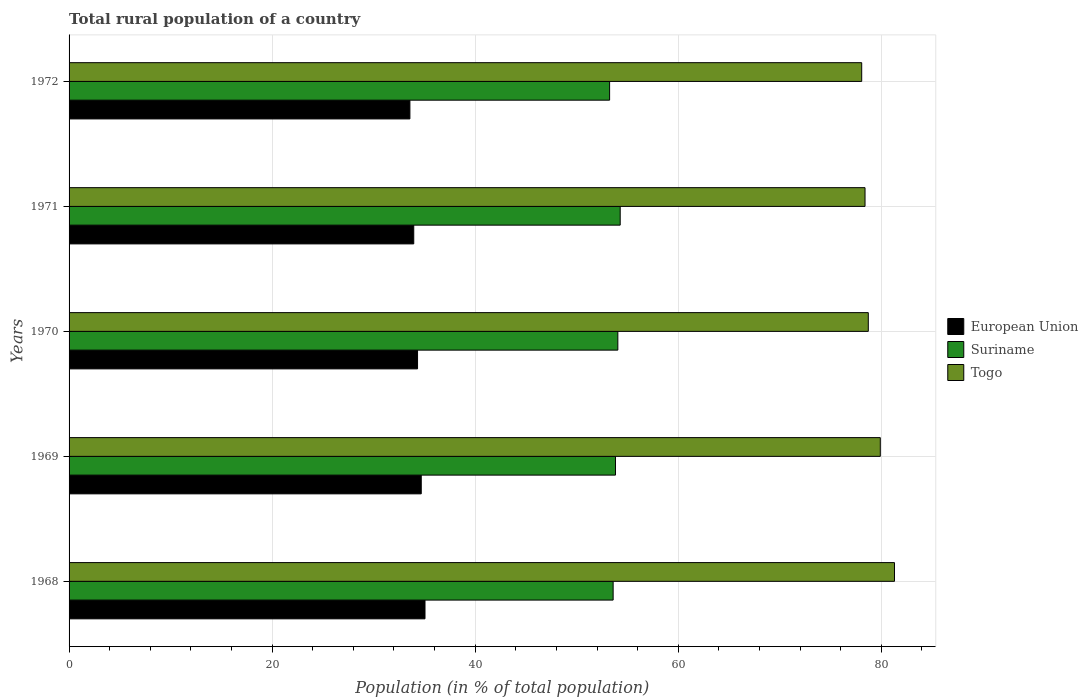How many different coloured bars are there?
Keep it short and to the point. 3. How many bars are there on the 5th tick from the top?
Give a very brief answer. 3. How many bars are there on the 5th tick from the bottom?
Your answer should be very brief. 3. What is the rural population in Togo in 1969?
Ensure brevity in your answer.  79.9. Across all years, what is the maximum rural population in Togo?
Offer a terse response. 81.3. Across all years, what is the minimum rural population in Togo?
Offer a terse response. 78.07. In which year was the rural population in Togo maximum?
Provide a short and direct response. 1968. In which year was the rural population in Suriname minimum?
Make the answer very short. 1972. What is the total rural population in European Union in the graph?
Provide a succinct answer. 171.59. What is the difference between the rural population in Togo in 1971 and that in 1972?
Keep it short and to the point. 0.33. What is the difference between the rural population in Togo in 1971 and the rural population in European Union in 1969?
Offer a terse response. 43.71. What is the average rural population in Suriname per year?
Provide a short and direct response. 53.8. In the year 1971, what is the difference between the rural population in European Union and rural population in Togo?
Offer a very short reply. -44.45. In how many years, is the rural population in Suriname greater than 64 %?
Provide a succinct answer. 0. What is the ratio of the rural population in Togo in 1968 to that in 1971?
Offer a very short reply. 1.04. What is the difference between the highest and the second highest rural population in Togo?
Your answer should be very brief. 1.4. What is the difference between the highest and the lowest rural population in European Union?
Give a very brief answer. 1.49. In how many years, is the rural population in European Union greater than the average rural population in European Union taken over all years?
Your answer should be very brief. 3. Is the sum of the rural population in Togo in 1968 and 1972 greater than the maximum rural population in European Union across all years?
Provide a short and direct response. Yes. What does the 3rd bar from the top in 1968 represents?
Your answer should be compact. European Union. What does the 2nd bar from the bottom in 1968 represents?
Your response must be concise. Suriname. Is it the case that in every year, the sum of the rural population in Suriname and rural population in European Union is greater than the rural population in Togo?
Provide a short and direct response. Yes. How many bars are there?
Offer a terse response. 15. How many years are there in the graph?
Make the answer very short. 5. Does the graph contain grids?
Your answer should be compact. Yes. Where does the legend appear in the graph?
Your answer should be compact. Center right. How many legend labels are there?
Keep it short and to the point. 3. How are the legend labels stacked?
Offer a terse response. Vertical. What is the title of the graph?
Make the answer very short. Total rural population of a country. Does "Aruba" appear as one of the legend labels in the graph?
Ensure brevity in your answer.  No. What is the label or title of the X-axis?
Offer a very short reply. Population (in % of total population). What is the Population (in % of total population) in European Union in 1968?
Offer a terse response. 35.06. What is the Population (in % of total population) of Suriname in 1968?
Provide a short and direct response. 53.59. What is the Population (in % of total population) of Togo in 1968?
Your response must be concise. 81.3. What is the Population (in % of total population) in European Union in 1969?
Give a very brief answer. 34.69. What is the Population (in % of total population) of Suriname in 1969?
Your answer should be very brief. 53.82. What is the Population (in % of total population) in Togo in 1969?
Your answer should be very brief. 79.9. What is the Population (in % of total population) of European Union in 1970?
Make the answer very short. 34.32. What is the Population (in % of total population) in Suriname in 1970?
Your response must be concise. 54.05. What is the Population (in % of total population) in Togo in 1970?
Give a very brief answer. 78.72. What is the Population (in % of total population) in European Union in 1971?
Offer a terse response. 33.95. What is the Population (in % of total population) in Suriname in 1971?
Give a very brief answer. 54.28. What is the Population (in % of total population) in Togo in 1971?
Keep it short and to the point. 78.4. What is the Population (in % of total population) of European Union in 1972?
Give a very brief answer. 33.57. What is the Population (in % of total population) of Suriname in 1972?
Ensure brevity in your answer.  53.24. What is the Population (in % of total population) in Togo in 1972?
Make the answer very short. 78.07. Across all years, what is the maximum Population (in % of total population) of European Union?
Ensure brevity in your answer.  35.06. Across all years, what is the maximum Population (in % of total population) of Suriname?
Provide a succinct answer. 54.28. Across all years, what is the maximum Population (in % of total population) of Togo?
Provide a short and direct response. 81.3. Across all years, what is the minimum Population (in % of total population) of European Union?
Keep it short and to the point. 33.57. Across all years, what is the minimum Population (in % of total population) in Suriname?
Give a very brief answer. 53.24. Across all years, what is the minimum Population (in % of total population) in Togo?
Provide a succinct answer. 78.07. What is the total Population (in % of total population) of European Union in the graph?
Provide a succinct answer. 171.59. What is the total Population (in % of total population) of Suriname in the graph?
Your answer should be very brief. 268.98. What is the total Population (in % of total population) of Togo in the graph?
Your answer should be very brief. 396.39. What is the difference between the Population (in % of total population) of European Union in 1968 and that in 1969?
Ensure brevity in your answer.  0.37. What is the difference between the Population (in % of total population) of Suriname in 1968 and that in 1969?
Give a very brief answer. -0.23. What is the difference between the Population (in % of total population) in Togo in 1968 and that in 1969?
Offer a very short reply. 1.4. What is the difference between the Population (in % of total population) of European Union in 1968 and that in 1970?
Your answer should be compact. 0.73. What is the difference between the Population (in % of total population) of Suriname in 1968 and that in 1970?
Provide a short and direct response. -0.46. What is the difference between the Population (in % of total population) in Togo in 1968 and that in 1970?
Your response must be concise. 2.58. What is the difference between the Population (in % of total population) of European Union in 1968 and that in 1971?
Provide a short and direct response. 1.11. What is the difference between the Population (in % of total population) of Suriname in 1968 and that in 1971?
Provide a short and direct response. -0.7. What is the difference between the Population (in % of total population) in Togo in 1968 and that in 1971?
Provide a succinct answer. 2.9. What is the difference between the Population (in % of total population) of European Union in 1968 and that in 1972?
Provide a short and direct response. 1.49. What is the difference between the Population (in % of total population) of Suriname in 1968 and that in 1972?
Make the answer very short. 0.35. What is the difference between the Population (in % of total population) in Togo in 1968 and that in 1972?
Provide a succinct answer. 3.23. What is the difference between the Population (in % of total population) in European Union in 1969 and that in 1970?
Provide a succinct answer. 0.37. What is the difference between the Population (in % of total population) of Suriname in 1969 and that in 1970?
Offer a terse response. -0.23. What is the difference between the Population (in % of total population) of Togo in 1969 and that in 1970?
Your answer should be very brief. 1.18. What is the difference between the Population (in % of total population) in European Union in 1969 and that in 1971?
Offer a very short reply. 0.74. What is the difference between the Population (in % of total population) in Suriname in 1969 and that in 1971?
Offer a terse response. -0.46. What is the difference between the Population (in % of total population) in Togo in 1969 and that in 1971?
Provide a succinct answer. 1.5. What is the difference between the Population (in % of total population) of European Union in 1969 and that in 1972?
Offer a terse response. 1.12. What is the difference between the Population (in % of total population) in Suriname in 1969 and that in 1972?
Your response must be concise. 0.58. What is the difference between the Population (in % of total population) in Togo in 1969 and that in 1972?
Provide a succinct answer. 1.83. What is the difference between the Population (in % of total population) in European Union in 1970 and that in 1971?
Offer a terse response. 0.37. What is the difference between the Population (in % of total population) in Suriname in 1970 and that in 1971?
Provide a short and direct response. -0.23. What is the difference between the Population (in % of total population) of Togo in 1970 and that in 1971?
Give a very brief answer. 0.32. What is the difference between the Population (in % of total population) of European Union in 1970 and that in 1972?
Keep it short and to the point. 0.75. What is the difference between the Population (in % of total population) of Suriname in 1970 and that in 1972?
Keep it short and to the point. 0.81. What is the difference between the Population (in % of total population) in Togo in 1970 and that in 1972?
Offer a terse response. 0.65. What is the difference between the Population (in % of total population) of European Union in 1971 and that in 1972?
Offer a terse response. 0.38. What is the difference between the Population (in % of total population) of Suriname in 1971 and that in 1972?
Your answer should be compact. 1.04. What is the difference between the Population (in % of total population) of Togo in 1971 and that in 1972?
Provide a short and direct response. 0.33. What is the difference between the Population (in % of total population) in European Union in 1968 and the Population (in % of total population) in Suriname in 1969?
Your answer should be compact. -18.76. What is the difference between the Population (in % of total population) of European Union in 1968 and the Population (in % of total population) of Togo in 1969?
Give a very brief answer. -44.84. What is the difference between the Population (in % of total population) in Suriname in 1968 and the Population (in % of total population) in Togo in 1969?
Your response must be concise. -26.31. What is the difference between the Population (in % of total population) in European Union in 1968 and the Population (in % of total population) in Suriname in 1970?
Ensure brevity in your answer.  -18.99. What is the difference between the Population (in % of total population) of European Union in 1968 and the Population (in % of total population) of Togo in 1970?
Give a very brief answer. -43.66. What is the difference between the Population (in % of total population) of Suriname in 1968 and the Population (in % of total population) of Togo in 1970?
Your answer should be very brief. -25.13. What is the difference between the Population (in % of total population) in European Union in 1968 and the Population (in % of total population) in Suriname in 1971?
Make the answer very short. -19.23. What is the difference between the Population (in % of total population) of European Union in 1968 and the Population (in % of total population) of Togo in 1971?
Your answer should be very brief. -43.34. What is the difference between the Population (in % of total population) of Suriname in 1968 and the Population (in % of total population) of Togo in 1971?
Ensure brevity in your answer.  -24.81. What is the difference between the Population (in % of total population) in European Union in 1968 and the Population (in % of total population) in Suriname in 1972?
Keep it short and to the point. -18.18. What is the difference between the Population (in % of total population) of European Union in 1968 and the Population (in % of total population) of Togo in 1972?
Provide a succinct answer. -43.01. What is the difference between the Population (in % of total population) of Suriname in 1968 and the Population (in % of total population) of Togo in 1972?
Your answer should be compact. -24.48. What is the difference between the Population (in % of total population) of European Union in 1969 and the Population (in % of total population) of Suriname in 1970?
Make the answer very short. -19.36. What is the difference between the Population (in % of total population) in European Union in 1969 and the Population (in % of total population) in Togo in 1970?
Offer a very short reply. -44.03. What is the difference between the Population (in % of total population) of Suriname in 1969 and the Population (in % of total population) of Togo in 1970?
Provide a short and direct response. -24.9. What is the difference between the Population (in % of total population) in European Union in 1969 and the Population (in % of total population) in Suriname in 1971?
Make the answer very short. -19.6. What is the difference between the Population (in % of total population) in European Union in 1969 and the Population (in % of total population) in Togo in 1971?
Your answer should be compact. -43.71. What is the difference between the Population (in % of total population) in Suriname in 1969 and the Population (in % of total population) in Togo in 1971?
Ensure brevity in your answer.  -24.58. What is the difference between the Population (in % of total population) in European Union in 1969 and the Population (in % of total population) in Suriname in 1972?
Your answer should be very brief. -18.55. What is the difference between the Population (in % of total population) of European Union in 1969 and the Population (in % of total population) of Togo in 1972?
Ensure brevity in your answer.  -43.38. What is the difference between the Population (in % of total population) of Suriname in 1969 and the Population (in % of total population) of Togo in 1972?
Keep it short and to the point. -24.25. What is the difference between the Population (in % of total population) in European Union in 1970 and the Population (in % of total population) in Suriname in 1971?
Offer a very short reply. -19.96. What is the difference between the Population (in % of total population) of European Union in 1970 and the Population (in % of total population) of Togo in 1971?
Provide a succinct answer. -44.07. What is the difference between the Population (in % of total population) in Suriname in 1970 and the Population (in % of total population) in Togo in 1971?
Provide a short and direct response. -24.35. What is the difference between the Population (in % of total population) of European Union in 1970 and the Population (in % of total population) of Suriname in 1972?
Your answer should be compact. -18.92. What is the difference between the Population (in % of total population) of European Union in 1970 and the Population (in % of total population) of Togo in 1972?
Your answer should be very brief. -43.75. What is the difference between the Population (in % of total population) in Suriname in 1970 and the Population (in % of total population) in Togo in 1972?
Make the answer very short. -24.02. What is the difference between the Population (in % of total population) of European Union in 1971 and the Population (in % of total population) of Suriname in 1972?
Offer a very short reply. -19.29. What is the difference between the Population (in % of total population) of European Union in 1971 and the Population (in % of total population) of Togo in 1972?
Give a very brief answer. -44.12. What is the difference between the Population (in % of total population) in Suriname in 1971 and the Population (in % of total population) in Togo in 1972?
Offer a terse response. -23.79. What is the average Population (in % of total population) of European Union per year?
Your response must be concise. 34.32. What is the average Population (in % of total population) of Suriname per year?
Offer a very short reply. 53.8. What is the average Population (in % of total population) in Togo per year?
Give a very brief answer. 79.28. In the year 1968, what is the difference between the Population (in % of total population) of European Union and Population (in % of total population) of Suriname?
Your response must be concise. -18.53. In the year 1968, what is the difference between the Population (in % of total population) of European Union and Population (in % of total population) of Togo?
Provide a succinct answer. -46.24. In the year 1968, what is the difference between the Population (in % of total population) in Suriname and Population (in % of total population) in Togo?
Offer a very short reply. -27.71. In the year 1969, what is the difference between the Population (in % of total population) in European Union and Population (in % of total population) in Suriname?
Keep it short and to the point. -19.13. In the year 1969, what is the difference between the Population (in % of total population) of European Union and Population (in % of total population) of Togo?
Offer a terse response. -45.21. In the year 1969, what is the difference between the Population (in % of total population) in Suriname and Population (in % of total population) in Togo?
Give a very brief answer. -26.08. In the year 1970, what is the difference between the Population (in % of total population) in European Union and Population (in % of total population) in Suriname?
Make the answer very short. -19.73. In the year 1970, what is the difference between the Population (in % of total population) of European Union and Population (in % of total population) of Togo?
Provide a succinct answer. -44.4. In the year 1970, what is the difference between the Population (in % of total population) in Suriname and Population (in % of total population) in Togo?
Keep it short and to the point. -24.67. In the year 1971, what is the difference between the Population (in % of total population) in European Union and Population (in % of total population) in Suriname?
Your answer should be very brief. -20.34. In the year 1971, what is the difference between the Population (in % of total population) of European Union and Population (in % of total population) of Togo?
Your response must be concise. -44.45. In the year 1971, what is the difference between the Population (in % of total population) of Suriname and Population (in % of total population) of Togo?
Your answer should be very brief. -24.11. In the year 1972, what is the difference between the Population (in % of total population) of European Union and Population (in % of total population) of Suriname?
Ensure brevity in your answer.  -19.67. In the year 1972, what is the difference between the Population (in % of total population) in European Union and Population (in % of total population) in Togo?
Your answer should be compact. -44.5. In the year 1972, what is the difference between the Population (in % of total population) in Suriname and Population (in % of total population) in Togo?
Your answer should be very brief. -24.83. What is the ratio of the Population (in % of total population) of European Union in 1968 to that in 1969?
Provide a short and direct response. 1.01. What is the ratio of the Population (in % of total population) of Suriname in 1968 to that in 1969?
Give a very brief answer. 1. What is the ratio of the Population (in % of total population) in Togo in 1968 to that in 1969?
Offer a very short reply. 1.02. What is the ratio of the Population (in % of total population) of European Union in 1968 to that in 1970?
Your answer should be compact. 1.02. What is the ratio of the Population (in % of total population) of Suriname in 1968 to that in 1970?
Provide a short and direct response. 0.99. What is the ratio of the Population (in % of total population) of Togo in 1968 to that in 1970?
Make the answer very short. 1.03. What is the ratio of the Population (in % of total population) in European Union in 1968 to that in 1971?
Your answer should be compact. 1.03. What is the ratio of the Population (in % of total population) in Suriname in 1968 to that in 1971?
Your answer should be compact. 0.99. What is the ratio of the Population (in % of total population) in Togo in 1968 to that in 1971?
Give a very brief answer. 1.04. What is the ratio of the Population (in % of total population) in European Union in 1968 to that in 1972?
Provide a succinct answer. 1.04. What is the ratio of the Population (in % of total population) of Togo in 1968 to that in 1972?
Keep it short and to the point. 1.04. What is the ratio of the Population (in % of total population) in European Union in 1969 to that in 1970?
Your answer should be very brief. 1.01. What is the ratio of the Population (in % of total population) of Suriname in 1969 to that in 1970?
Ensure brevity in your answer.  1. What is the ratio of the Population (in % of total population) in Togo in 1969 to that in 1970?
Provide a short and direct response. 1.01. What is the ratio of the Population (in % of total population) in European Union in 1969 to that in 1971?
Give a very brief answer. 1.02. What is the ratio of the Population (in % of total population) of Suriname in 1969 to that in 1971?
Your answer should be compact. 0.99. What is the ratio of the Population (in % of total population) of Togo in 1969 to that in 1971?
Provide a short and direct response. 1.02. What is the ratio of the Population (in % of total population) of Suriname in 1969 to that in 1972?
Keep it short and to the point. 1.01. What is the ratio of the Population (in % of total population) in Togo in 1969 to that in 1972?
Ensure brevity in your answer.  1.02. What is the ratio of the Population (in % of total population) in Suriname in 1970 to that in 1971?
Keep it short and to the point. 1. What is the ratio of the Population (in % of total population) of European Union in 1970 to that in 1972?
Your response must be concise. 1.02. What is the ratio of the Population (in % of total population) of Suriname in 1970 to that in 1972?
Give a very brief answer. 1.02. What is the ratio of the Population (in % of total population) in Togo in 1970 to that in 1972?
Offer a very short reply. 1.01. What is the ratio of the Population (in % of total population) of European Union in 1971 to that in 1972?
Make the answer very short. 1.01. What is the ratio of the Population (in % of total population) in Suriname in 1971 to that in 1972?
Your response must be concise. 1.02. What is the difference between the highest and the second highest Population (in % of total population) in European Union?
Offer a terse response. 0.37. What is the difference between the highest and the second highest Population (in % of total population) of Suriname?
Your response must be concise. 0.23. What is the difference between the highest and the second highest Population (in % of total population) in Togo?
Give a very brief answer. 1.4. What is the difference between the highest and the lowest Population (in % of total population) in European Union?
Provide a short and direct response. 1.49. What is the difference between the highest and the lowest Population (in % of total population) in Suriname?
Your answer should be compact. 1.04. What is the difference between the highest and the lowest Population (in % of total population) of Togo?
Your answer should be compact. 3.23. 